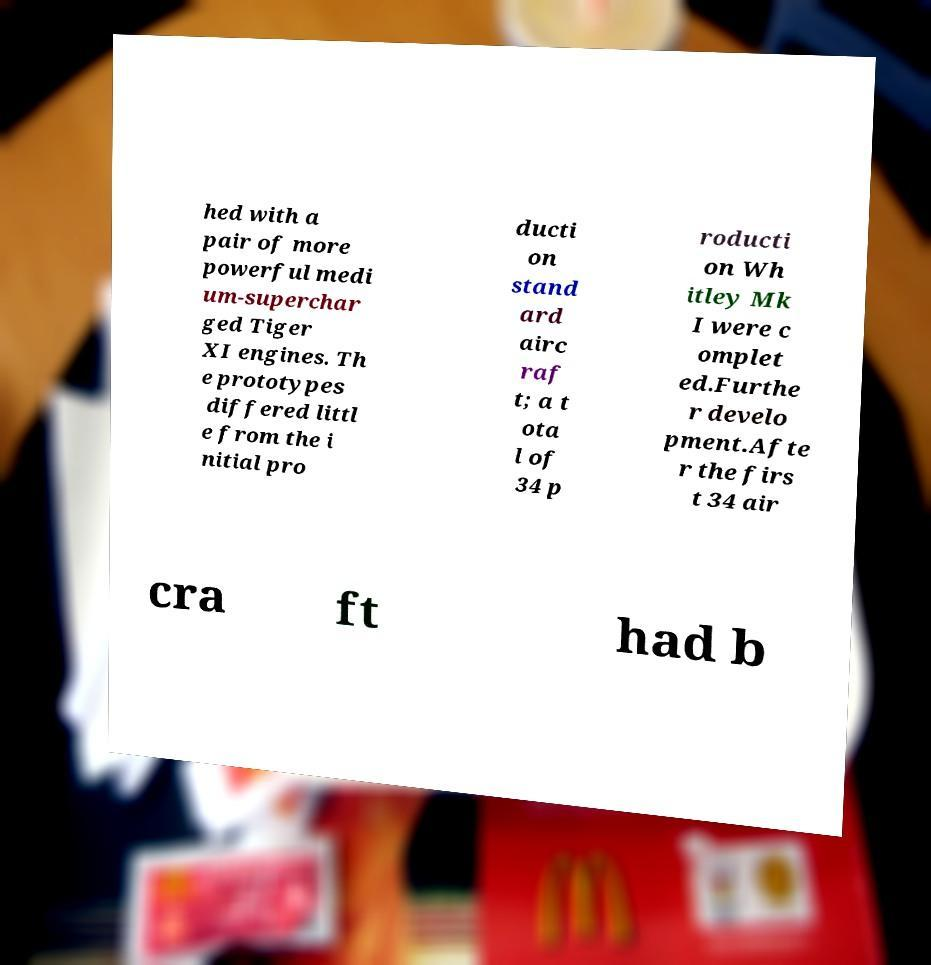I need the written content from this picture converted into text. Can you do that? hed with a pair of more powerful medi um-superchar ged Tiger XI engines. Th e prototypes differed littl e from the i nitial pro ducti on stand ard airc raf t; a t ota l of 34 p roducti on Wh itley Mk I were c omplet ed.Furthe r develo pment.Afte r the firs t 34 air cra ft had b 